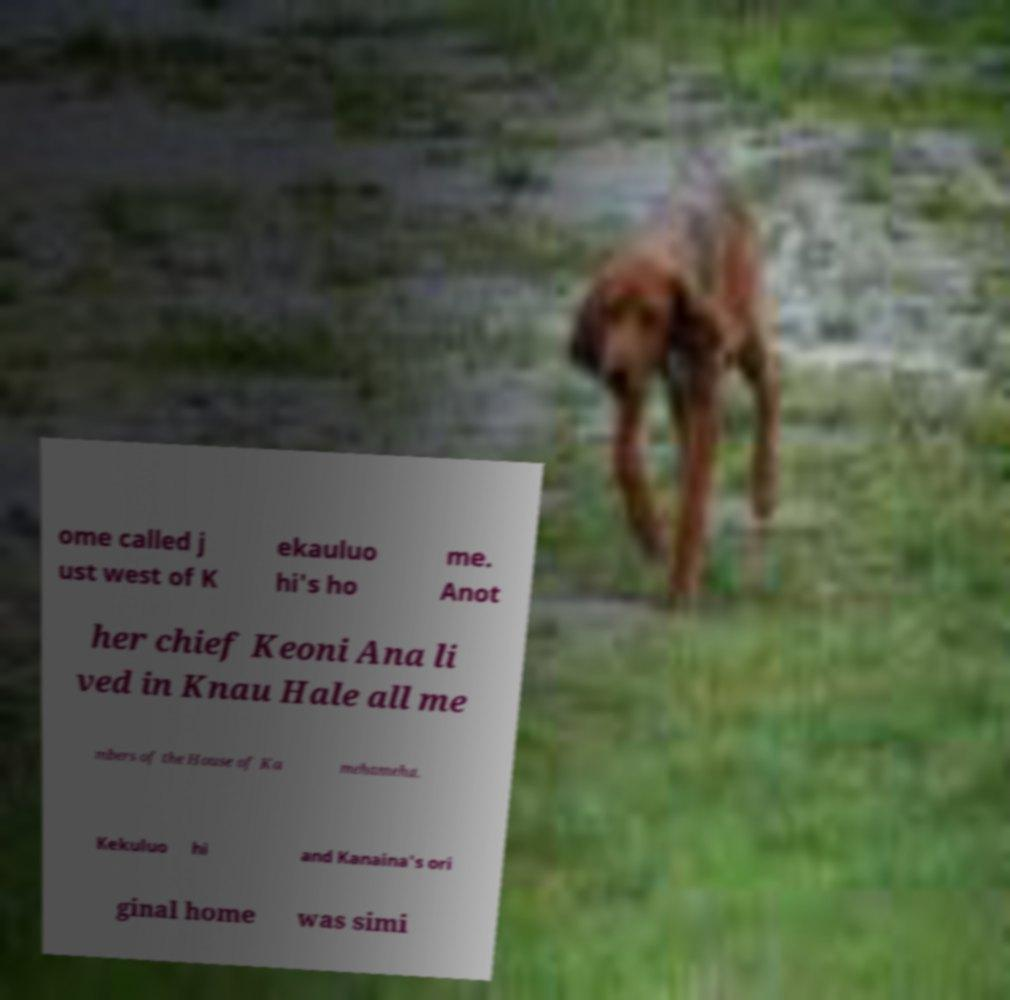What messages or text are displayed in this image? I need them in a readable, typed format. ome called j ust west of K ekauluo hi's ho me. Anot her chief Keoni Ana li ved in Knau Hale all me mbers of the House of Ka mehameha. Kekuluo hi and Kanaina's ori ginal home was simi 